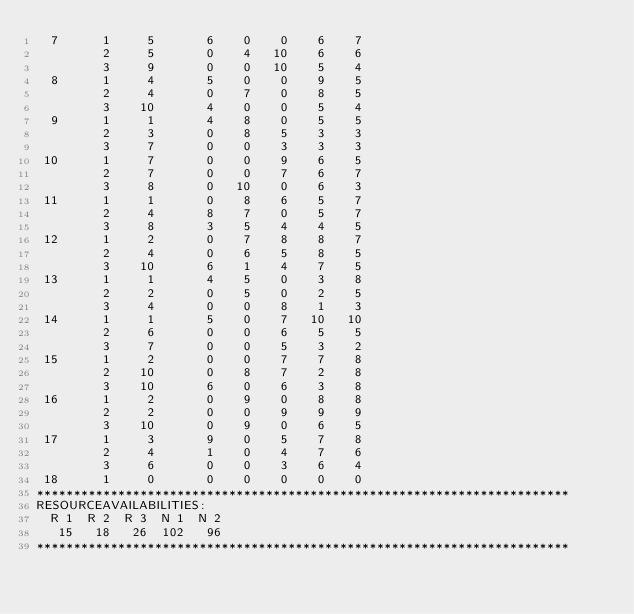<code> <loc_0><loc_0><loc_500><loc_500><_ObjectiveC_>  7      1     5       6    0    0    6    7
         2     5       0    4   10    6    6
         3     9       0    0   10    5    4
  8      1     4       5    0    0    9    5
         2     4       0    7    0    8    5
         3    10       4    0    0    5    4
  9      1     1       4    8    0    5    5
         2     3       0    8    5    3    3
         3     7       0    0    3    3    3
 10      1     7       0    0    9    6    5
         2     7       0    0    7    6    7
         3     8       0   10    0    6    3
 11      1     1       0    8    6    5    7
         2     4       8    7    0    5    7
         3     8       3    5    4    4    5
 12      1     2       0    7    8    8    7
         2     4       0    6    5    8    5
         3    10       6    1    4    7    5
 13      1     1       4    5    0    3    8
         2     2       0    5    0    2    5
         3     4       0    0    8    1    3
 14      1     1       5    0    7   10   10
         2     6       0    0    6    5    5
         3     7       0    0    5    3    2
 15      1     2       0    0    7    7    8
         2    10       0    8    7    2    8
         3    10       6    0    6    3    8
 16      1     2       0    9    0    8    8
         2     2       0    0    9    9    9
         3    10       0    9    0    6    5
 17      1     3       9    0    5    7    8
         2     4       1    0    4    7    6
         3     6       0    0    3    6    4
 18      1     0       0    0    0    0    0
************************************************************************
RESOURCEAVAILABILITIES:
  R 1  R 2  R 3  N 1  N 2
   15   18   26  102   96
************************************************************************
</code> 